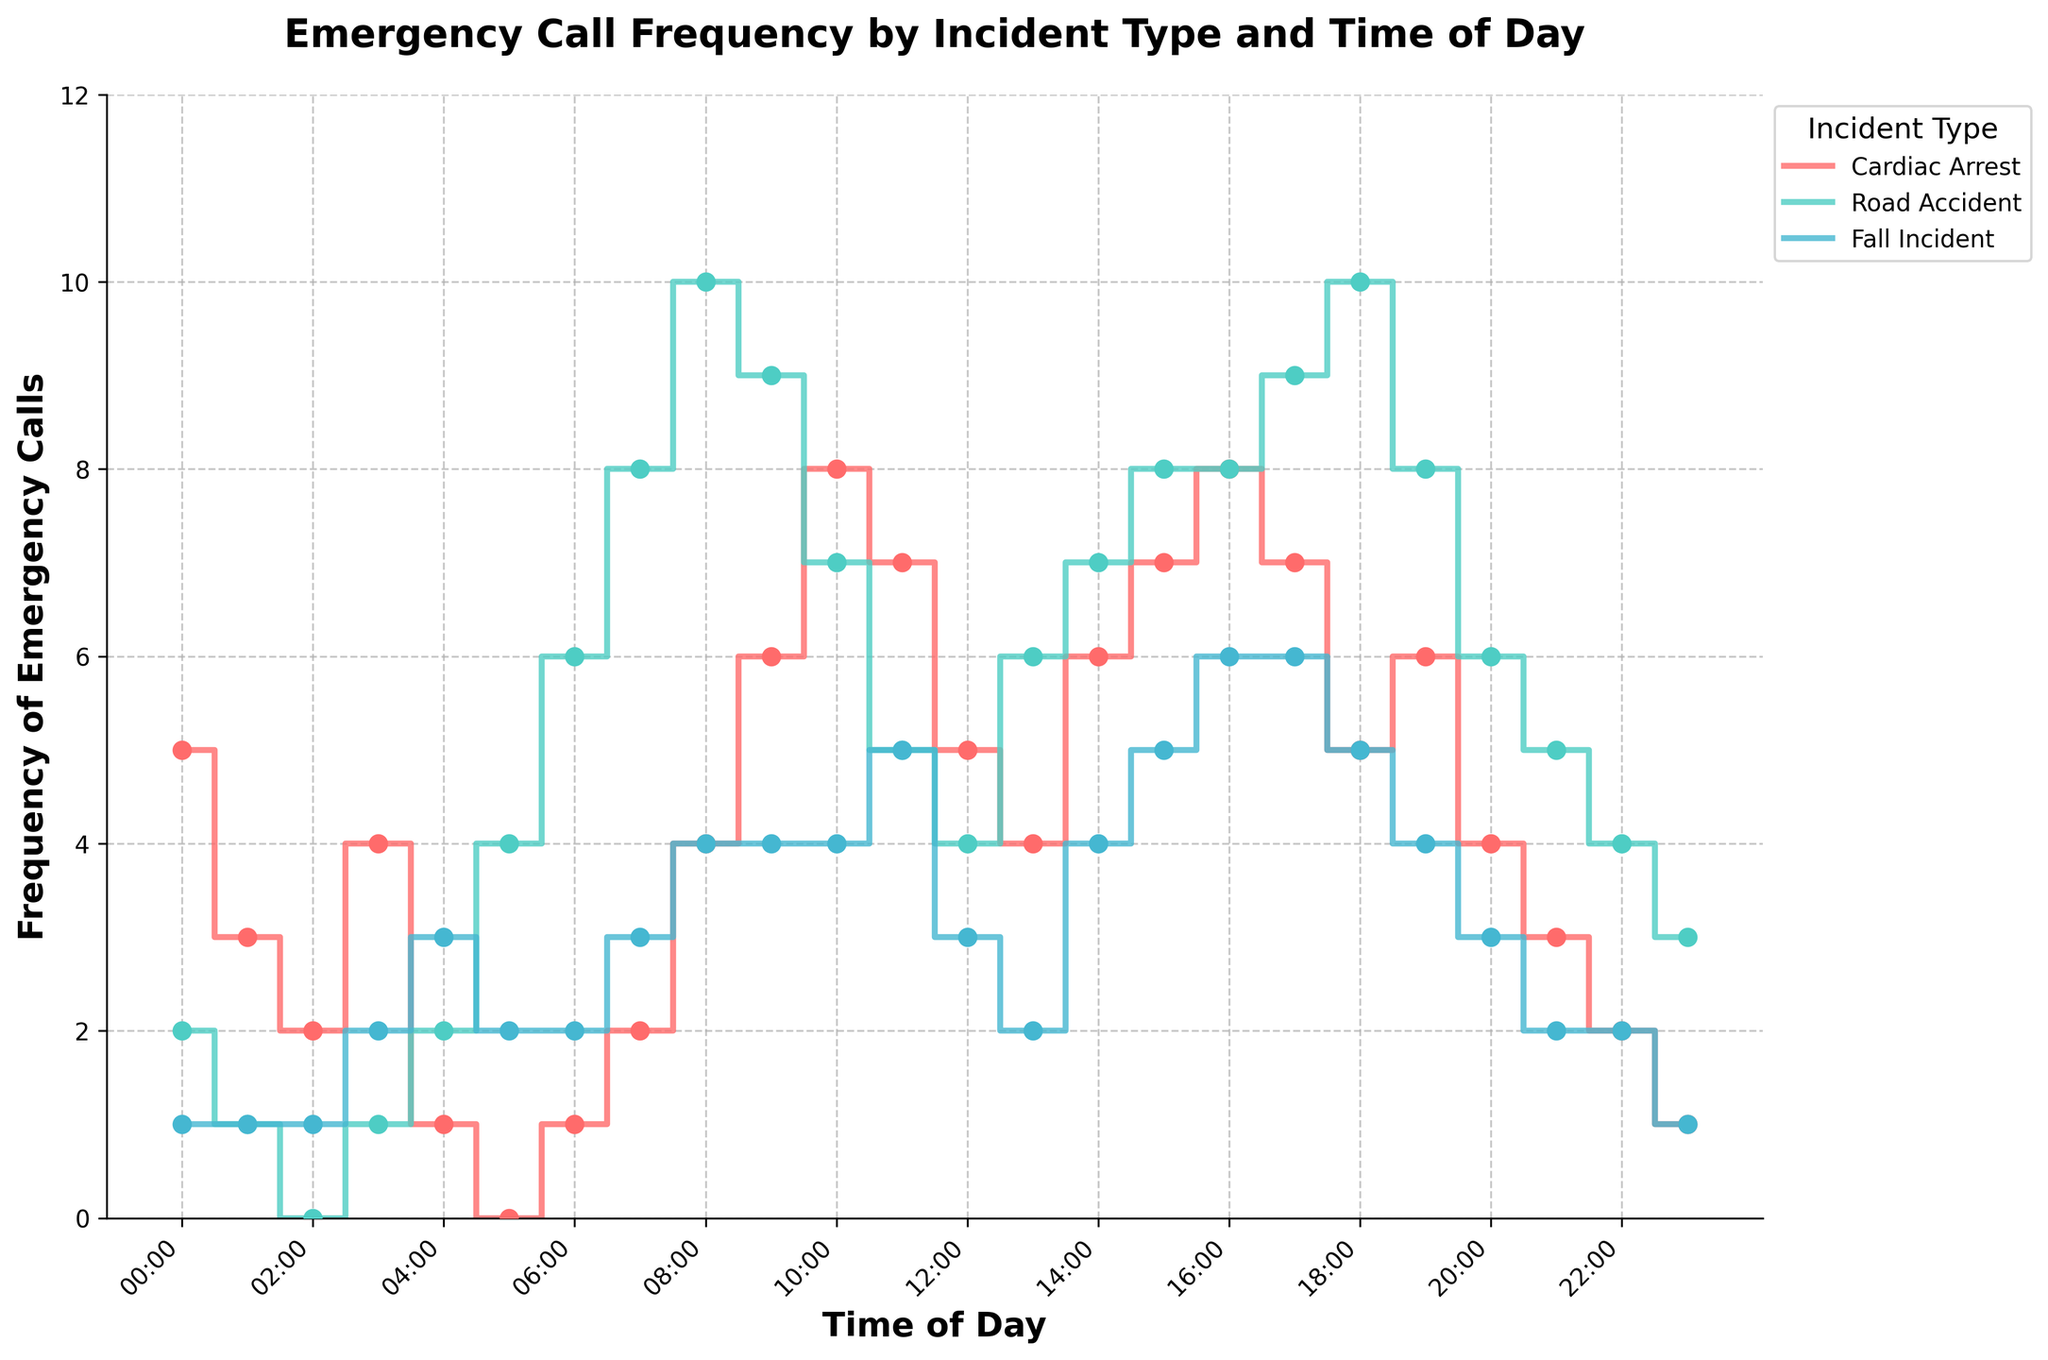What is the title of the plot? The title is displayed at the top of the plot and reads 'Emergency Call Frequency by Incident Type and Time of Day'.
Answer: Emergency Call Frequency by Incident Type and Time of Day How many unique types of incidents are displayed in the plot? The legend to the right of the plot shows three unique incident types: Cardiac Arrest, Road Accident, and Fall Incident.
Answer: 3 Which time of day has the highest frequency of Road Accidents? The plot shows the highest point on the Road Accident line, which peaks at 08:00-09:00 and 18:00-19:00, both with a frequency of 10.
Answer: 08:00-09:00 and 18:00-19:00 What is the frequency of Cardiac Arrest calls at 15:00-16:00? By locating the 15:00-16:00 time slot on the x-axis and observing the corresponding point on the Cardiac Arrest line, the frequency is shown as 7.
Answer: 7 What is the difference in the number of Fall Incidents between 16:00-17:00 and 06:00-07:00? The frequency of Fall Incidents at 16:00-17:00 is 6, and at 06:00-07:00 it is 2. The difference is calculated as 6 - 2.
Answer: 4 Which incident type shows the most calls during the 10:00-11:00 window? By comparing the frequencies for each incident type at 10:00-11:00, Road Accident has a frequency of 7, Cardiac Arrest has 8, and Fall Incident has 4. Cardiac Arrest has the highest frequency.
Answer: Cardiac Arrest During which time intervals do all three incident types show calls? Checking each time interval, 08:00-09:00 and 10:00-11:00 show frequencies greater than zero for all three incident types.
Answer: 08:00-09:00 and 10:00-11:00 What is the average frequency of Road Accident calls from 06:00 to 10:00? The frequencies from 06:00-07:00 to 09:00-10:00 are 6, 8, 10, and 9. Adding them gives 33, and dividing by 4 (the number of intervals) gives 33 / 4 = 8.25.
Answer: 8.25 Compare the trend of Cardiac Arrest calls with Road Accident calls between 18:00-24:00. Observing the respective lines, Cardiac Arrest decreases from 7 to 1, while Road Accident decreases from 10 to 3, showing a higher initial drop for Road Accident.
Answer: Road Accident shows a steeper decline What is the overall trend of Fall Incidents over the entire day? Observing the line for Fall Incidents, it shows fluctuations with an overall upward trend during morning to afternoon and a relatively stable to downward trend in the evening.
Answer: Fluctuating, with morning-to-afternoon uptrend, evening stable to downtrend 